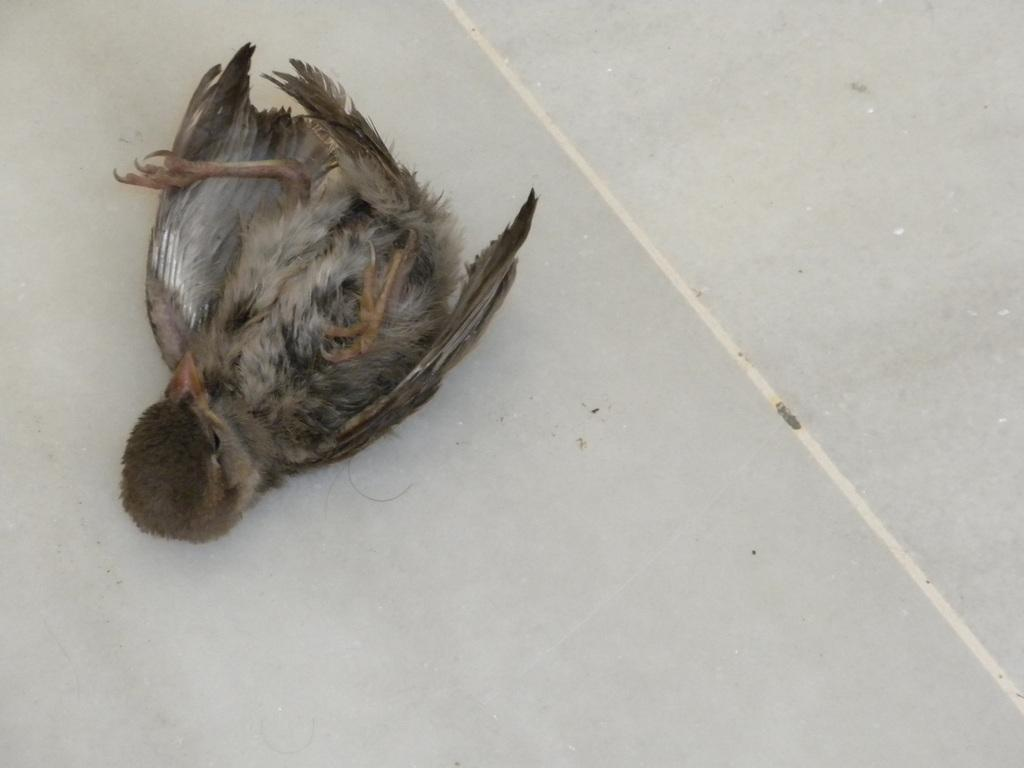What is at the bottom of the image? There is a floor at the bottom of the image. What color is the floor? The floor is white in color. What can be seen in the middle of the image? There is a bird in the middle of the image. Where is the bird located? The bird is on the floor. What type of crack can be heard in the image? There is no crack or sound present in the image; it is a still image featuring a bird on a white floor. 